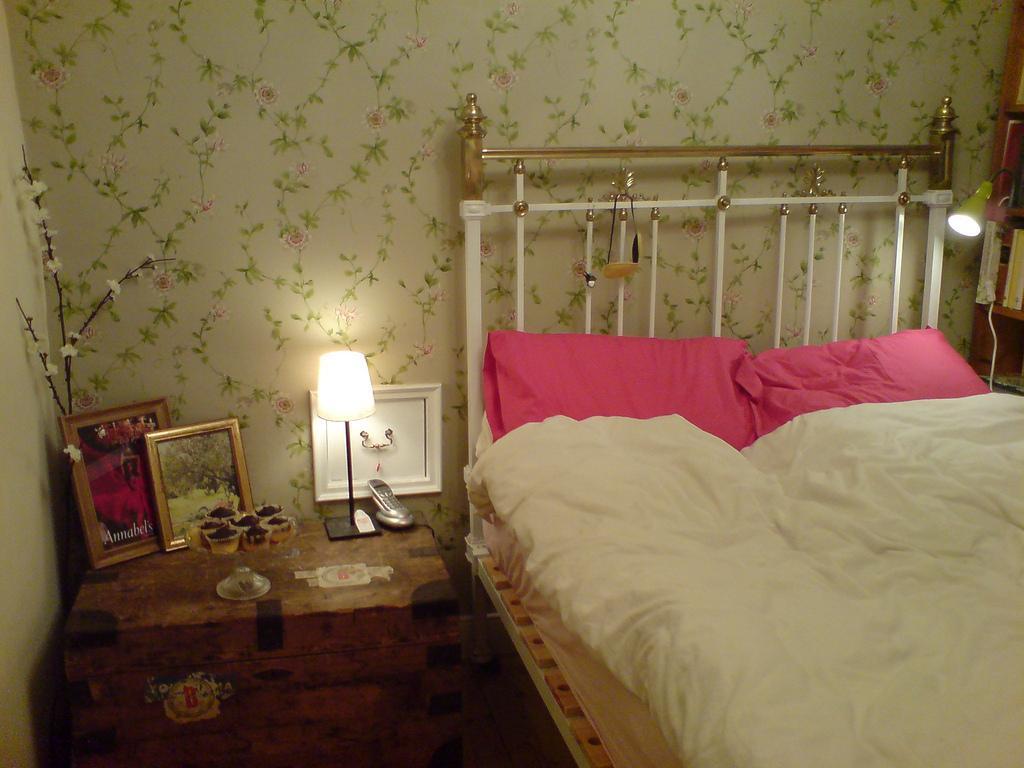Describe this image in one or two sentences. In this image we can see a bed with the pillows on it. We can also see a table beside it containing the photo frames, a plant with flowers, a lamp, a telephone and a glass on it. On the right side we can see a lamp and a group of books placed in the shelves. We can also see the walls. 